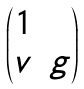<formula> <loc_0><loc_0><loc_500><loc_500>\begin{pmatrix} 1 & \\ v & g \end{pmatrix}</formula> 